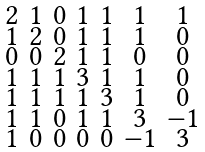<formula> <loc_0><loc_0><loc_500><loc_500>\begin{smallmatrix} 2 & 1 & 0 & 1 & 1 & 1 & 1 \\ 1 & 2 & 0 & 1 & 1 & 1 & 0 \\ 0 & 0 & 2 & 1 & 1 & 0 & 0 \\ 1 & 1 & 1 & 3 & 1 & 1 & 0 \\ 1 & 1 & 1 & 1 & 3 & 1 & 0 \\ 1 & 1 & 0 & 1 & 1 & 3 & - 1 \\ 1 & 0 & 0 & 0 & 0 & - 1 & 3 \end{smallmatrix}</formula> 